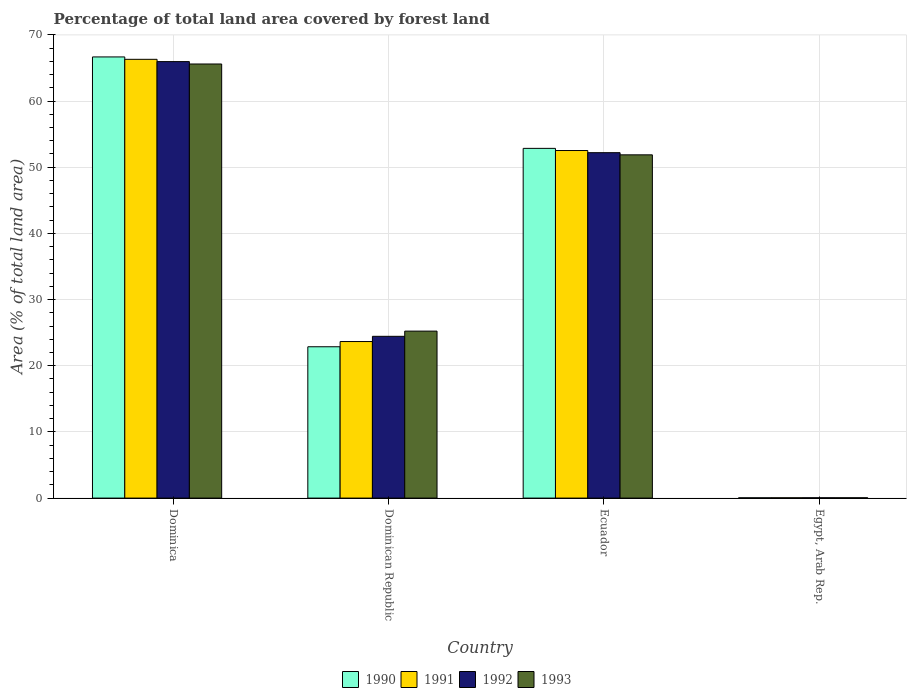How many different coloured bars are there?
Provide a short and direct response. 4. How many groups of bars are there?
Offer a terse response. 4. How many bars are there on the 3rd tick from the left?
Your answer should be very brief. 4. What is the label of the 3rd group of bars from the left?
Give a very brief answer. Ecuador. What is the percentage of forest land in 1992 in Egypt, Arab Rep.?
Provide a succinct answer. 0.05. Across all countries, what is the maximum percentage of forest land in 1991?
Make the answer very short. 66.31. Across all countries, what is the minimum percentage of forest land in 1993?
Provide a short and direct response. 0.05. In which country was the percentage of forest land in 1992 maximum?
Provide a succinct answer. Dominica. In which country was the percentage of forest land in 1991 minimum?
Your response must be concise. Egypt, Arab Rep. What is the total percentage of forest land in 1993 in the graph?
Keep it short and to the point. 142.75. What is the difference between the percentage of forest land in 1993 in Dominican Republic and that in Ecuador?
Your answer should be compact. -26.64. What is the difference between the percentage of forest land in 1992 in Dominican Republic and the percentage of forest land in 1990 in Dominica?
Offer a terse response. -42.22. What is the average percentage of forest land in 1993 per country?
Offer a very short reply. 35.69. What is the difference between the percentage of forest land of/in 1993 and percentage of forest land of/in 1990 in Dominican Republic?
Offer a very short reply. 2.37. What is the ratio of the percentage of forest land in 1992 in Dominican Republic to that in Egypt, Arab Rep.?
Provide a short and direct response. 517.75. Is the percentage of forest land in 1992 in Dominica less than that in Ecuador?
Your answer should be very brief. No. What is the difference between the highest and the second highest percentage of forest land in 1990?
Provide a short and direct response. 13.82. What is the difference between the highest and the lowest percentage of forest land in 1992?
Offer a very short reply. 65.91. In how many countries, is the percentage of forest land in 1993 greater than the average percentage of forest land in 1993 taken over all countries?
Make the answer very short. 2. Is the sum of the percentage of forest land in 1992 in Dominica and Dominican Republic greater than the maximum percentage of forest land in 1990 across all countries?
Offer a terse response. Yes. What does the 3rd bar from the right in Egypt, Arab Rep. represents?
Ensure brevity in your answer.  1991. How many bars are there?
Provide a short and direct response. 16. How many countries are there in the graph?
Provide a succinct answer. 4. What is the difference between two consecutive major ticks on the Y-axis?
Ensure brevity in your answer.  10. Does the graph contain any zero values?
Offer a very short reply. No. Where does the legend appear in the graph?
Your answer should be compact. Bottom center. How many legend labels are there?
Your answer should be compact. 4. How are the legend labels stacked?
Your answer should be compact. Horizontal. What is the title of the graph?
Provide a succinct answer. Percentage of total land area covered by forest land. Does "2000" appear as one of the legend labels in the graph?
Give a very brief answer. No. What is the label or title of the X-axis?
Give a very brief answer. Country. What is the label or title of the Y-axis?
Offer a terse response. Area (% of total land area). What is the Area (% of total land area) of 1990 in Dominica?
Your answer should be very brief. 66.67. What is the Area (% of total land area) in 1991 in Dominica?
Your answer should be compact. 66.31. What is the Area (% of total land area) in 1992 in Dominica?
Offer a terse response. 65.96. What is the Area (% of total land area) in 1993 in Dominica?
Your response must be concise. 65.6. What is the Area (% of total land area) of 1990 in Dominican Republic?
Ensure brevity in your answer.  22.87. What is the Area (% of total land area) of 1991 in Dominican Republic?
Your answer should be compact. 23.66. What is the Area (% of total land area) of 1992 in Dominican Republic?
Keep it short and to the point. 24.45. What is the Area (% of total land area) of 1993 in Dominican Republic?
Give a very brief answer. 25.23. What is the Area (% of total land area) in 1990 in Ecuador?
Your response must be concise. 52.85. What is the Area (% of total land area) in 1991 in Ecuador?
Your answer should be very brief. 52.52. What is the Area (% of total land area) in 1992 in Ecuador?
Your answer should be compact. 52.2. What is the Area (% of total land area) of 1993 in Ecuador?
Your response must be concise. 51.87. What is the Area (% of total land area) in 1990 in Egypt, Arab Rep.?
Ensure brevity in your answer.  0.04. What is the Area (% of total land area) in 1991 in Egypt, Arab Rep.?
Ensure brevity in your answer.  0.05. What is the Area (% of total land area) of 1992 in Egypt, Arab Rep.?
Offer a terse response. 0.05. What is the Area (% of total land area) of 1993 in Egypt, Arab Rep.?
Keep it short and to the point. 0.05. Across all countries, what is the maximum Area (% of total land area) of 1990?
Offer a very short reply. 66.67. Across all countries, what is the maximum Area (% of total land area) in 1991?
Give a very brief answer. 66.31. Across all countries, what is the maximum Area (% of total land area) of 1992?
Your response must be concise. 65.96. Across all countries, what is the maximum Area (% of total land area) of 1993?
Ensure brevity in your answer.  65.6. Across all countries, what is the minimum Area (% of total land area) of 1990?
Make the answer very short. 0.04. Across all countries, what is the minimum Area (% of total land area) of 1991?
Your response must be concise. 0.05. Across all countries, what is the minimum Area (% of total land area) in 1992?
Your response must be concise. 0.05. Across all countries, what is the minimum Area (% of total land area) in 1993?
Your response must be concise. 0.05. What is the total Area (% of total land area) in 1990 in the graph?
Keep it short and to the point. 142.43. What is the total Area (% of total land area) of 1991 in the graph?
Your answer should be compact. 142.53. What is the total Area (% of total land area) of 1992 in the graph?
Your answer should be very brief. 142.65. What is the total Area (% of total land area) in 1993 in the graph?
Provide a succinct answer. 142.75. What is the difference between the Area (% of total land area) of 1990 in Dominica and that in Dominican Republic?
Make the answer very short. 43.8. What is the difference between the Area (% of total land area) in 1991 in Dominica and that in Dominican Republic?
Keep it short and to the point. 42.65. What is the difference between the Area (% of total land area) of 1992 in Dominica and that in Dominican Republic?
Give a very brief answer. 41.51. What is the difference between the Area (% of total land area) of 1993 in Dominica and that in Dominican Republic?
Your answer should be compact. 40.37. What is the difference between the Area (% of total land area) of 1990 in Dominica and that in Ecuador?
Ensure brevity in your answer.  13.82. What is the difference between the Area (% of total land area) in 1991 in Dominica and that in Ecuador?
Give a very brief answer. 13.78. What is the difference between the Area (% of total land area) of 1992 in Dominica and that in Ecuador?
Provide a short and direct response. 13.76. What is the difference between the Area (% of total land area) of 1993 in Dominica and that in Ecuador?
Keep it short and to the point. 13.73. What is the difference between the Area (% of total land area) of 1990 in Dominica and that in Egypt, Arab Rep.?
Give a very brief answer. 66.62. What is the difference between the Area (% of total land area) of 1991 in Dominica and that in Egypt, Arab Rep.?
Provide a short and direct response. 66.26. What is the difference between the Area (% of total land area) of 1992 in Dominica and that in Egypt, Arab Rep.?
Keep it short and to the point. 65.91. What is the difference between the Area (% of total land area) in 1993 in Dominica and that in Egypt, Arab Rep.?
Provide a succinct answer. 65.55. What is the difference between the Area (% of total land area) in 1990 in Dominican Republic and that in Ecuador?
Offer a very short reply. -29.98. What is the difference between the Area (% of total land area) of 1991 in Dominican Republic and that in Ecuador?
Your answer should be very brief. -28.87. What is the difference between the Area (% of total land area) in 1992 in Dominican Republic and that in Ecuador?
Provide a succinct answer. -27.75. What is the difference between the Area (% of total land area) of 1993 in Dominican Republic and that in Ecuador?
Provide a succinct answer. -26.64. What is the difference between the Area (% of total land area) in 1990 in Dominican Republic and that in Egypt, Arab Rep.?
Your answer should be very brief. 22.82. What is the difference between the Area (% of total land area) of 1991 in Dominican Republic and that in Egypt, Arab Rep.?
Your response must be concise. 23.61. What is the difference between the Area (% of total land area) of 1992 in Dominican Republic and that in Egypt, Arab Rep.?
Keep it short and to the point. 24.4. What is the difference between the Area (% of total land area) in 1993 in Dominican Republic and that in Egypt, Arab Rep.?
Provide a succinct answer. 25.19. What is the difference between the Area (% of total land area) in 1990 in Ecuador and that in Egypt, Arab Rep.?
Provide a short and direct response. 52.81. What is the difference between the Area (% of total land area) of 1991 in Ecuador and that in Egypt, Arab Rep.?
Your response must be concise. 52.48. What is the difference between the Area (% of total land area) of 1992 in Ecuador and that in Egypt, Arab Rep.?
Ensure brevity in your answer.  52.15. What is the difference between the Area (% of total land area) of 1993 in Ecuador and that in Egypt, Arab Rep.?
Make the answer very short. 51.82. What is the difference between the Area (% of total land area) in 1990 in Dominica and the Area (% of total land area) in 1991 in Dominican Republic?
Offer a very short reply. 43.01. What is the difference between the Area (% of total land area) in 1990 in Dominica and the Area (% of total land area) in 1992 in Dominican Republic?
Give a very brief answer. 42.22. What is the difference between the Area (% of total land area) in 1990 in Dominica and the Area (% of total land area) in 1993 in Dominican Republic?
Keep it short and to the point. 41.43. What is the difference between the Area (% of total land area) of 1991 in Dominica and the Area (% of total land area) of 1992 in Dominican Republic?
Provide a short and direct response. 41.86. What is the difference between the Area (% of total land area) in 1991 in Dominica and the Area (% of total land area) in 1993 in Dominican Republic?
Provide a short and direct response. 41.07. What is the difference between the Area (% of total land area) in 1992 in Dominica and the Area (% of total land area) in 1993 in Dominican Republic?
Ensure brevity in your answer.  40.73. What is the difference between the Area (% of total land area) of 1990 in Dominica and the Area (% of total land area) of 1991 in Ecuador?
Provide a succinct answer. 14.14. What is the difference between the Area (% of total land area) in 1990 in Dominica and the Area (% of total land area) in 1992 in Ecuador?
Offer a terse response. 14.47. What is the difference between the Area (% of total land area) of 1990 in Dominica and the Area (% of total land area) of 1993 in Ecuador?
Keep it short and to the point. 14.79. What is the difference between the Area (% of total land area) in 1991 in Dominica and the Area (% of total land area) in 1992 in Ecuador?
Give a very brief answer. 14.11. What is the difference between the Area (% of total land area) in 1991 in Dominica and the Area (% of total land area) in 1993 in Ecuador?
Offer a terse response. 14.43. What is the difference between the Area (% of total land area) in 1992 in Dominica and the Area (% of total land area) in 1993 in Ecuador?
Provide a short and direct response. 14.09. What is the difference between the Area (% of total land area) of 1990 in Dominica and the Area (% of total land area) of 1991 in Egypt, Arab Rep.?
Keep it short and to the point. 66.62. What is the difference between the Area (% of total land area) of 1990 in Dominica and the Area (% of total land area) of 1992 in Egypt, Arab Rep.?
Offer a terse response. 66.62. What is the difference between the Area (% of total land area) in 1990 in Dominica and the Area (% of total land area) in 1993 in Egypt, Arab Rep.?
Your answer should be compact. 66.62. What is the difference between the Area (% of total land area) of 1991 in Dominica and the Area (% of total land area) of 1992 in Egypt, Arab Rep.?
Keep it short and to the point. 66.26. What is the difference between the Area (% of total land area) in 1991 in Dominica and the Area (% of total land area) in 1993 in Egypt, Arab Rep.?
Offer a very short reply. 66.26. What is the difference between the Area (% of total land area) of 1992 in Dominica and the Area (% of total land area) of 1993 in Egypt, Arab Rep.?
Keep it short and to the point. 65.91. What is the difference between the Area (% of total land area) of 1990 in Dominican Republic and the Area (% of total land area) of 1991 in Ecuador?
Your answer should be very brief. -29.66. What is the difference between the Area (% of total land area) in 1990 in Dominican Republic and the Area (% of total land area) in 1992 in Ecuador?
Provide a succinct answer. -29.33. What is the difference between the Area (% of total land area) in 1990 in Dominican Republic and the Area (% of total land area) in 1993 in Ecuador?
Give a very brief answer. -29. What is the difference between the Area (% of total land area) of 1991 in Dominican Republic and the Area (% of total land area) of 1992 in Ecuador?
Your answer should be very brief. -28.54. What is the difference between the Area (% of total land area) of 1991 in Dominican Republic and the Area (% of total land area) of 1993 in Ecuador?
Make the answer very short. -28.22. What is the difference between the Area (% of total land area) in 1992 in Dominican Republic and the Area (% of total land area) in 1993 in Ecuador?
Offer a very short reply. -27.43. What is the difference between the Area (% of total land area) of 1990 in Dominican Republic and the Area (% of total land area) of 1991 in Egypt, Arab Rep.?
Give a very brief answer. 22.82. What is the difference between the Area (% of total land area) of 1990 in Dominican Republic and the Area (% of total land area) of 1992 in Egypt, Arab Rep.?
Give a very brief answer. 22.82. What is the difference between the Area (% of total land area) in 1990 in Dominican Republic and the Area (% of total land area) in 1993 in Egypt, Arab Rep.?
Your response must be concise. 22.82. What is the difference between the Area (% of total land area) of 1991 in Dominican Republic and the Area (% of total land area) of 1992 in Egypt, Arab Rep.?
Make the answer very short. 23.61. What is the difference between the Area (% of total land area) of 1991 in Dominican Republic and the Area (% of total land area) of 1993 in Egypt, Arab Rep.?
Keep it short and to the point. 23.61. What is the difference between the Area (% of total land area) in 1992 in Dominican Republic and the Area (% of total land area) in 1993 in Egypt, Arab Rep.?
Your response must be concise. 24.4. What is the difference between the Area (% of total land area) of 1990 in Ecuador and the Area (% of total land area) of 1991 in Egypt, Arab Rep.?
Offer a very short reply. 52.8. What is the difference between the Area (% of total land area) in 1990 in Ecuador and the Area (% of total land area) in 1992 in Egypt, Arab Rep.?
Your response must be concise. 52.8. What is the difference between the Area (% of total land area) in 1990 in Ecuador and the Area (% of total land area) in 1993 in Egypt, Arab Rep.?
Provide a succinct answer. 52.8. What is the difference between the Area (% of total land area) in 1991 in Ecuador and the Area (% of total land area) in 1992 in Egypt, Arab Rep.?
Offer a very short reply. 52.48. What is the difference between the Area (% of total land area) of 1991 in Ecuador and the Area (% of total land area) of 1993 in Egypt, Arab Rep.?
Keep it short and to the point. 52.47. What is the difference between the Area (% of total land area) in 1992 in Ecuador and the Area (% of total land area) in 1993 in Egypt, Arab Rep.?
Your answer should be very brief. 52.15. What is the average Area (% of total land area) in 1990 per country?
Make the answer very short. 35.61. What is the average Area (% of total land area) of 1991 per country?
Give a very brief answer. 35.63. What is the average Area (% of total land area) in 1992 per country?
Your answer should be compact. 35.66. What is the average Area (% of total land area) of 1993 per country?
Your answer should be very brief. 35.69. What is the difference between the Area (% of total land area) in 1990 and Area (% of total land area) in 1991 in Dominica?
Ensure brevity in your answer.  0.36. What is the difference between the Area (% of total land area) in 1990 and Area (% of total land area) in 1992 in Dominica?
Provide a succinct answer. 0.71. What is the difference between the Area (% of total land area) of 1990 and Area (% of total land area) of 1993 in Dominica?
Provide a short and direct response. 1.07. What is the difference between the Area (% of total land area) of 1991 and Area (% of total land area) of 1992 in Dominica?
Offer a very short reply. 0.35. What is the difference between the Area (% of total land area) of 1991 and Area (% of total land area) of 1993 in Dominica?
Make the answer very short. 0.71. What is the difference between the Area (% of total land area) in 1992 and Area (% of total land area) in 1993 in Dominica?
Provide a succinct answer. 0.36. What is the difference between the Area (% of total land area) of 1990 and Area (% of total land area) of 1991 in Dominican Republic?
Your answer should be compact. -0.79. What is the difference between the Area (% of total land area) in 1990 and Area (% of total land area) in 1992 in Dominican Republic?
Ensure brevity in your answer.  -1.58. What is the difference between the Area (% of total land area) of 1990 and Area (% of total land area) of 1993 in Dominican Republic?
Make the answer very short. -2.37. What is the difference between the Area (% of total land area) in 1991 and Area (% of total land area) in 1992 in Dominican Republic?
Your answer should be compact. -0.79. What is the difference between the Area (% of total land area) in 1991 and Area (% of total land area) in 1993 in Dominican Republic?
Your response must be concise. -1.58. What is the difference between the Area (% of total land area) in 1992 and Area (% of total land area) in 1993 in Dominican Republic?
Make the answer very short. -0.79. What is the difference between the Area (% of total land area) in 1990 and Area (% of total land area) in 1991 in Ecuador?
Offer a terse response. 0.33. What is the difference between the Area (% of total land area) in 1990 and Area (% of total land area) in 1992 in Ecuador?
Keep it short and to the point. 0.65. What is the difference between the Area (% of total land area) of 1990 and Area (% of total land area) of 1993 in Ecuador?
Your response must be concise. 0.98. What is the difference between the Area (% of total land area) of 1991 and Area (% of total land area) of 1992 in Ecuador?
Your response must be concise. 0.33. What is the difference between the Area (% of total land area) in 1991 and Area (% of total land area) in 1993 in Ecuador?
Provide a short and direct response. 0.65. What is the difference between the Area (% of total land area) in 1992 and Area (% of total land area) in 1993 in Ecuador?
Your answer should be very brief. 0.33. What is the difference between the Area (% of total land area) in 1990 and Area (% of total land area) in 1991 in Egypt, Arab Rep.?
Keep it short and to the point. -0. What is the difference between the Area (% of total land area) of 1990 and Area (% of total land area) of 1992 in Egypt, Arab Rep.?
Give a very brief answer. -0. What is the difference between the Area (% of total land area) in 1990 and Area (% of total land area) in 1993 in Egypt, Arab Rep.?
Your answer should be compact. -0. What is the difference between the Area (% of total land area) in 1991 and Area (% of total land area) in 1992 in Egypt, Arab Rep.?
Keep it short and to the point. -0. What is the difference between the Area (% of total land area) of 1991 and Area (% of total land area) of 1993 in Egypt, Arab Rep.?
Keep it short and to the point. -0. What is the difference between the Area (% of total land area) of 1992 and Area (% of total land area) of 1993 in Egypt, Arab Rep.?
Keep it short and to the point. -0. What is the ratio of the Area (% of total land area) of 1990 in Dominica to that in Dominican Republic?
Provide a short and direct response. 2.92. What is the ratio of the Area (% of total land area) of 1991 in Dominica to that in Dominican Republic?
Offer a terse response. 2.8. What is the ratio of the Area (% of total land area) of 1992 in Dominica to that in Dominican Republic?
Your response must be concise. 2.7. What is the ratio of the Area (% of total land area) in 1993 in Dominica to that in Dominican Republic?
Offer a very short reply. 2.6. What is the ratio of the Area (% of total land area) of 1990 in Dominica to that in Ecuador?
Offer a terse response. 1.26. What is the ratio of the Area (% of total land area) in 1991 in Dominica to that in Ecuador?
Provide a succinct answer. 1.26. What is the ratio of the Area (% of total land area) of 1992 in Dominica to that in Ecuador?
Give a very brief answer. 1.26. What is the ratio of the Area (% of total land area) of 1993 in Dominica to that in Ecuador?
Your response must be concise. 1.26. What is the ratio of the Area (% of total land area) in 1990 in Dominica to that in Egypt, Arab Rep.?
Keep it short and to the point. 1508.26. What is the ratio of the Area (% of total land area) in 1991 in Dominica to that in Egypt, Arab Rep.?
Keep it short and to the point. 1450.66. What is the ratio of the Area (% of total land area) of 1992 in Dominica to that in Egypt, Arab Rep.?
Your answer should be compact. 1397.02. What is the ratio of the Area (% of total land area) of 1993 in Dominica to that in Egypt, Arab Rep.?
Offer a very short reply. 1346.42. What is the ratio of the Area (% of total land area) in 1990 in Dominican Republic to that in Ecuador?
Give a very brief answer. 0.43. What is the ratio of the Area (% of total land area) in 1991 in Dominican Republic to that in Ecuador?
Keep it short and to the point. 0.45. What is the ratio of the Area (% of total land area) in 1992 in Dominican Republic to that in Ecuador?
Offer a very short reply. 0.47. What is the ratio of the Area (% of total land area) of 1993 in Dominican Republic to that in Ecuador?
Provide a short and direct response. 0.49. What is the ratio of the Area (% of total land area) in 1990 in Dominican Republic to that in Egypt, Arab Rep.?
Your answer should be very brief. 517.37. What is the ratio of the Area (% of total land area) of 1991 in Dominican Republic to that in Egypt, Arab Rep.?
Provide a short and direct response. 517.57. What is the ratio of the Area (% of total land area) in 1992 in Dominican Republic to that in Egypt, Arab Rep.?
Give a very brief answer. 517.75. What is the ratio of the Area (% of total land area) of 1993 in Dominican Republic to that in Egypt, Arab Rep.?
Keep it short and to the point. 517.92. What is the ratio of the Area (% of total land area) of 1990 in Ecuador to that in Egypt, Arab Rep.?
Provide a succinct answer. 1195.66. What is the ratio of the Area (% of total land area) in 1991 in Ecuador to that in Egypt, Arab Rep.?
Your response must be concise. 1149.11. What is the ratio of the Area (% of total land area) of 1992 in Ecuador to that in Egypt, Arab Rep.?
Your response must be concise. 1105.54. What is the ratio of the Area (% of total land area) in 1993 in Ecuador to that in Egypt, Arab Rep.?
Keep it short and to the point. 1064.66. What is the difference between the highest and the second highest Area (% of total land area) of 1990?
Provide a short and direct response. 13.82. What is the difference between the highest and the second highest Area (% of total land area) of 1991?
Your response must be concise. 13.78. What is the difference between the highest and the second highest Area (% of total land area) in 1992?
Give a very brief answer. 13.76. What is the difference between the highest and the second highest Area (% of total land area) in 1993?
Provide a succinct answer. 13.73. What is the difference between the highest and the lowest Area (% of total land area) of 1990?
Your response must be concise. 66.62. What is the difference between the highest and the lowest Area (% of total land area) of 1991?
Your answer should be very brief. 66.26. What is the difference between the highest and the lowest Area (% of total land area) of 1992?
Offer a terse response. 65.91. What is the difference between the highest and the lowest Area (% of total land area) in 1993?
Keep it short and to the point. 65.55. 